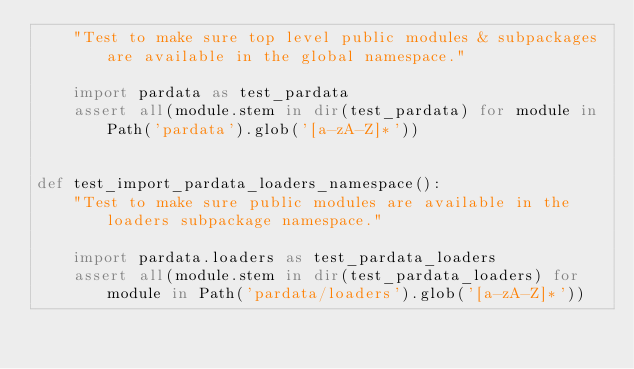<code> <loc_0><loc_0><loc_500><loc_500><_Python_>    "Test to make sure top level public modules & subpackages are available in the global namespace."

    import pardata as test_pardata
    assert all(module.stem in dir(test_pardata) for module in Path('pardata').glob('[a-zA-Z]*'))


def test_import_pardata_loaders_namespace():
    "Test to make sure public modules are available in the loaders subpackage namespace."

    import pardata.loaders as test_pardata_loaders
    assert all(module.stem in dir(test_pardata_loaders) for module in Path('pardata/loaders').glob('[a-zA-Z]*'))
</code> 